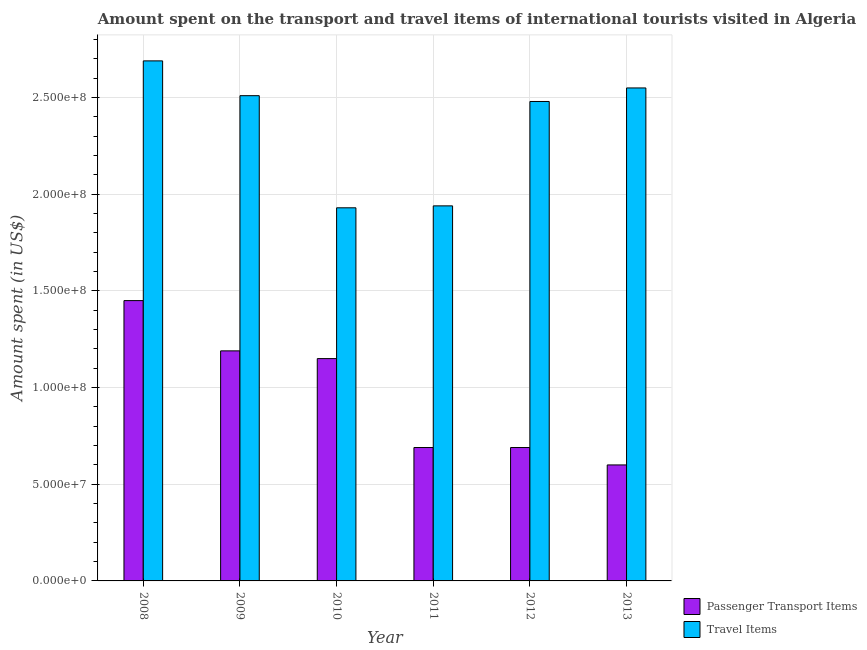Are the number of bars on each tick of the X-axis equal?
Offer a very short reply. Yes. How many bars are there on the 5th tick from the right?
Ensure brevity in your answer.  2. What is the label of the 2nd group of bars from the left?
Keep it short and to the point. 2009. What is the amount spent on passenger transport items in 2013?
Provide a short and direct response. 6.00e+07. Across all years, what is the maximum amount spent in travel items?
Offer a very short reply. 2.69e+08. Across all years, what is the minimum amount spent in travel items?
Provide a short and direct response. 1.93e+08. In which year was the amount spent on passenger transport items maximum?
Offer a terse response. 2008. In which year was the amount spent in travel items minimum?
Your response must be concise. 2010. What is the total amount spent on passenger transport items in the graph?
Offer a terse response. 5.77e+08. What is the difference between the amount spent in travel items in 2011 and that in 2013?
Make the answer very short. -6.10e+07. What is the difference between the amount spent in travel items in 2012 and the amount spent on passenger transport items in 2008?
Give a very brief answer. -2.10e+07. What is the average amount spent on passenger transport items per year?
Provide a short and direct response. 9.62e+07. What is the ratio of the amount spent in travel items in 2008 to that in 2011?
Give a very brief answer. 1.39. What is the difference between the highest and the second highest amount spent on passenger transport items?
Your answer should be compact. 2.60e+07. What is the difference between the highest and the lowest amount spent on passenger transport items?
Provide a short and direct response. 8.50e+07. Is the sum of the amount spent in travel items in 2010 and 2012 greater than the maximum amount spent on passenger transport items across all years?
Make the answer very short. Yes. What does the 2nd bar from the left in 2012 represents?
Provide a short and direct response. Travel Items. What does the 1st bar from the right in 2009 represents?
Your answer should be compact. Travel Items. How many bars are there?
Give a very brief answer. 12. Are all the bars in the graph horizontal?
Give a very brief answer. No. What is the difference between two consecutive major ticks on the Y-axis?
Your answer should be compact. 5.00e+07. Does the graph contain any zero values?
Make the answer very short. No. Does the graph contain grids?
Make the answer very short. Yes. Where does the legend appear in the graph?
Offer a terse response. Bottom right. How many legend labels are there?
Ensure brevity in your answer.  2. How are the legend labels stacked?
Ensure brevity in your answer.  Vertical. What is the title of the graph?
Your answer should be very brief. Amount spent on the transport and travel items of international tourists visited in Algeria. Does "Urban agglomerations" appear as one of the legend labels in the graph?
Your answer should be very brief. No. What is the label or title of the X-axis?
Offer a terse response. Year. What is the label or title of the Y-axis?
Your response must be concise. Amount spent (in US$). What is the Amount spent (in US$) of Passenger Transport Items in 2008?
Provide a succinct answer. 1.45e+08. What is the Amount spent (in US$) in Travel Items in 2008?
Your answer should be very brief. 2.69e+08. What is the Amount spent (in US$) in Passenger Transport Items in 2009?
Your answer should be compact. 1.19e+08. What is the Amount spent (in US$) of Travel Items in 2009?
Offer a very short reply. 2.51e+08. What is the Amount spent (in US$) in Passenger Transport Items in 2010?
Keep it short and to the point. 1.15e+08. What is the Amount spent (in US$) in Travel Items in 2010?
Your answer should be compact. 1.93e+08. What is the Amount spent (in US$) in Passenger Transport Items in 2011?
Your answer should be very brief. 6.90e+07. What is the Amount spent (in US$) of Travel Items in 2011?
Offer a very short reply. 1.94e+08. What is the Amount spent (in US$) of Passenger Transport Items in 2012?
Provide a succinct answer. 6.90e+07. What is the Amount spent (in US$) of Travel Items in 2012?
Provide a short and direct response. 2.48e+08. What is the Amount spent (in US$) in Passenger Transport Items in 2013?
Your response must be concise. 6.00e+07. What is the Amount spent (in US$) in Travel Items in 2013?
Offer a very short reply. 2.55e+08. Across all years, what is the maximum Amount spent (in US$) in Passenger Transport Items?
Keep it short and to the point. 1.45e+08. Across all years, what is the maximum Amount spent (in US$) of Travel Items?
Your answer should be very brief. 2.69e+08. Across all years, what is the minimum Amount spent (in US$) of Passenger Transport Items?
Make the answer very short. 6.00e+07. Across all years, what is the minimum Amount spent (in US$) in Travel Items?
Ensure brevity in your answer.  1.93e+08. What is the total Amount spent (in US$) in Passenger Transport Items in the graph?
Provide a short and direct response. 5.77e+08. What is the total Amount spent (in US$) of Travel Items in the graph?
Make the answer very short. 1.41e+09. What is the difference between the Amount spent (in US$) in Passenger Transport Items in 2008 and that in 2009?
Offer a terse response. 2.60e+07. What is the difference between the Amount spent (in US$) in Travel Items in 2008 and that in 2009?
Give a very brief answer. 1.80e+07. What is the difference between the Amount spent (in US$) in Passenger Transport Items in 2008 and that in 2010?
Your answer should be compact. 3.00e+07. What is the difference between the Amount spent (in US$) in Travel Items in 2008 and that in 2010?
Offer a terse response. 7.60e+07. What is the difference between the Amount spent (in US$) in Passenger Transport Items in 2008 and that in 2011?
Your answer should be very brief. 7.60e+07. What is the difference between the Amount spent (in US$) of Travel Items in 2008 and that in 2011?
Ensure brevity in your answer.  7.50e+07. What is the difference between the Amount spent (in US$) of Passenger Transport Items in 2008 and that in 2012?
Give a very brief answer. 7.60e+07. What is the difference between the Amount spent (in US$) in Travel Items in 2008 and that in 2012?
Ensure brevity in your answer.  2.10e+07. What is the difference between the Amount spent (in US$) in Passenger Transport Items in 2008 and that in 2013?
Offer a very short reply. 8.50e+07. What is the difference between the Amount spent (in US$) in Travel Items in 2008 and that in 2013?
Make the answer very short. 1.40e+07. What is the difference between the Amount spent (in US$) in Passenger Transport Items in 2009 and that in 2010?
Your answer should be very brief. 4.00e+06. What is the difference between the Amount spent (in US$) of Travel Items in 2009 and that in 2010?
Provide a short and direct response. 5.80e+07. What is the difference between the Amount spent (in US$) in Travel Items in 2009 and that in 2011?
Your response must be concise. 5.70e+07. What is the difference between the Amount spent (in US$) of Passenger Transport Items in 2009 and that in 2012?
Provide a succinct answer. 5.00e+07. What is the difference between the Amount spent (in US$) of Travel Items in 2009 and that in 2012?
Ensure brevity in your answer.  3.00e+06. What is the difference between the Amount spent (in US$) of Passenger Transport Items in 2009 and that in 2013?
Your answer should be compact. 5.90e+07. What is the difference between the Amount spent (in US$) in Travel Items in 2009 and that in 2013?
Provide a short and direct response. -4.00e+06. What is the difference between the Amount spent (in US$) in Passenger Transport Items in 2010 and that in 2011?
Offer a terse response. 4.60e+07. What is the difference between the Amount spent (in US$) in Travel Items in 2010 and that in 2011?
Provide a short and direct response. -1.00e+06. What is the difference between the Amount spent (in US$) in Passenger Transport Items in 2010 and that in 2012?
Ensure brevity in your answer.  4.60e+07. What is the difference between the Amount spent (in US$) in Travel Items in 2010 and that in 2012?
Your answer should be very brief. -5.50e+07. What is the difference between the Amount spent (in US$) of Passenger Transport Items in 2010 and that in 2013?
Your answer should be very brief. 5.50e+07. What is the difference between the Amount spent (in US$) of Travel Items in 2010 and that in 2013?
Provide a succinct answer. -6.20e+07. What is the difference between the Amount spent (in US$) of Passenger Transport Items in 2011 and that in 2012?
Make the answer very short. 0. What is the difference between the Amount spent (in US$) of Travel Items in 2011 and that in 2012?
Provide a short and direct response. -5.40e+07. What is the difference between the Amount spent (in US$) in Passenger Transport Items in 2011 and that in 2013?
Offer a very short reply. 9.00e+06. What is the difference between the Amount spent (in US$) of Travel Items in 2011 and that in 2013?
Offer a terse response. -6.10e+07. What is the difference between the Amount spent (in US$) of Passenger Transport Items in 2012 and that in 2013?
Ensure brevity in your answer.  9.00e+06. What is the difference between the Amount spent (in US$) in Travel Items in 2012 and that in 2013?
Make the answer very short. -7.00e+06. What is the difference between the Amount spent (in US$) in Passenger Transport Items in 2008 and the Amount spent (in US$) in Travel Items in 2009?
Keep it short and to the point. -1.06e+08. What is the difference between the Amount spent (in US$) of Passenger Transport Items in 2008 and the Amount spent (in US$) of Travel Items in 2010?
Your response must be concise. -4.80e+07. What is the difference between the Amount spent (in US$) of Passenger Transport Items in 2008 and the Amount spent (in US$) of Travel Items in 2011?
Provide a succinct answer. -4.90e+07. What is the difference between the Amount spent (in US$) in Passenger Transport Items in 2008 and the Amount spent (in US$) in Travel Items in 2012?
Keep it short and to the point. -1.03e+08. What is the difference between the Amount spent (in US$) of Passenger Transport Items in 2008 and the Amount spent (in US$) of Travel Items in 2013?
Offer a terse response. -1.10e+08. What is the difference between the Amount spent (in US$) in Passenger Transport Items in 2009 and the Amount spent (in US$) in Travel Items in 2010?
Offer a very short reply. -7.40e+07. What is the difference between the Amount spent (in US$) of Passenger Transport Items in 2009 and the Amount spent (in US$) of Travel Items in 2011?
Your answer should be compact. -7.50e+07. What is the difference between the Amount spent (in US$) in Passenger Transport Items in 2009 and the Amount spent (in US$) in Travel Items in 2012?
Your answer should be compact. -1.29e+08. What is the difference between the Amount spent (in US$) of Passenger Transport Items in 2009 and the Amount spent (in US$) of Travel Items in 2013?
Your answer should be compact. -1.36e+08. What is the difference between the Amount spent (in US$) of Passenger Transport Items in 2010 and the Amount spent (in US$) of Travel Items in 2011?
Ensure brevity in your answer.  -7.90e+07. What is the difference between the Amount spent (in US$) of Passenger Transport Items in 2010 and the Amount spent (in US$) of Travel Items in 2012?
Keep it short and to the point. -1.33e+08. What is the difference between the Amount spent (in US$) in Passenger Transport Items in 2010 and the Amount spent (in US$) in Travel Items in 2013?
Ensure brevity in your answer.  -1.40e+08. What is the difference between the Amount spent (in US$) of Passenger Transport Items in 2011 and the Amount spent (in US$) of Travel Items in 2012?
Your answer should be very brief. -1.79e+08. What is the difference between the Amount spent (in US$) in Passenger Transport Items in 2011 and the Amount spent (in US$) in Travel Items in 2013?
Keep it short and to the point. -1.86e+08. What is the difference between the Amount spent (in US$) of Passenger Transport Items in 2012 and the Amount spent (in US$) of Travel Items in 2013?
Provide a succinct answer. -1.86e+08. What is the average Amount spent (in US$) in Passenger Transport Items per year?
Offer a terse response. 9.62e+07. What is the average Amount spent (in US$) in Travel Items per year?
Provide a short and direct response. 2.35e+08. In the year 2008, what is the difference between the Amount spent (in US$) in Passenger Transport Items and Amount spent (in US$) in Travel Items?
Your answer should be very brief. -1.24e+08. In the year 2009, what is the difference between the Amount spent (in US$) of Passenger Transport Items and Amount spent (in US$) of Travel Items?
Your response must be concise. -1.32e+08. In the year 2010, what is the difference between the Amount spent (in US$) of Passenger Transport Items and Amount spent (in US$) of Travel Items?
Give a very brief answer. -7.80e+07. In the year 2011, what is the difference between the Amount spent (in US$) of Passenger Transport Items and Amount spent (in US$) of Travel Items?
Provide a succinct answer. -1.25e+08. In the year 2012, what is the difference between the Amount spent (in US$) of Passenger Transport Items and Amount spent (in US$) of Travel Items?
Provide a short and direct response. -1.79e+08. In the year 2013, what is the difference between the Amount spent (in US$) in Passenger Transport Items and Amount spent (in US$) in Travel Items?
Your response must be concise. -1.95e+08. What is the ratio of the Amount spent (in US$) in Passenger Transport Items in 2008 to that in 2009?
Provide a succinct answer. 1.22. What is the ratio of the Amount spent (in US$) in Travel Items in 2008 to that in 2009?
Your answer should be very brief. 1.07. What is the ratio of the Amount spent (in US$) in Passenger Transport Items in 2008 to that in 2010?
Offer a very short reply. 1.26. What is the ratio of the Amount spent (in US$) of Travel Items in 2008 to that in 2010?
Your answer should be very brief. 1.39. What is the ratio of the Amount spent (in US$) of Passenger Transport Items in 2008 to that in 2011?
Ensure brevity in your answer.  2.1. What is the ratio of the Amount spent (in US$) in Travel Items in 2008 to that in 2011?
Your answer should be compact. 1.39. What is the ratio of the Amount spent (in US$) of Passenger Transport Items in 2008 to that in 2012?
Your answer should be very brief. 2.1. What is the ratio of the Amount spent (in US$) of Travel Items in 2008 to that in 2012?
Give a very brief answer. 1.08. What is the ratio of the Amount spent (in US$) of Passenger Transport Items in 2008 to that in 2013?
Keep it short and to the point. 2.42. What is the ratio of the Amount spent (in US$) of Travel Items in 2008 to that in 2013?
Keep it short and to the point. 1.05. What is the ratio of the Amount spent (in US$) in Passenger Transport Items in 2009 to that in 2010?
Provide a short and direct response. 1.03. What is the ratio of the Amount spent (in US$) of Travel Items in 2009 to that in 2010?
Your response must be concise. 1.3. What is the ratio of the Amount spent (in US$) in Passenger Transport Items in 2009 to that in 2011?
Provide a succinct answer. 1.72. What is the ratio of the Amount spent (in US$) of Travel Items in 2009 to that in 2011?
Ensure brevity in your answer.  1.29. What is the ratio of the Amount spent (in US$) of Passenger Transport Items in 2009 to that in 2012?
Your response must be concise. 1.72. What is the ratio of the Amount spent (in US$) in Travel Items in 2009 to that in 2012?
Keep it short and to the point. 1.01. What is the ratio of the Amount spent (in US$) in Passenger Transport Items in 2009 to that in 2013?
Make the answer very short. 1.98. What is the ratio of the Amount spent (in US$) of Travel Items in 2009 to that in 2013?
Make the answer very short. 0.98. What is the ratio of the Amount spent (in US$) of Passenger Transport Items in 2010 to that in 2011?
Provide a succinct answer. 1.67. What is the ratio of the Amount spent (in US$) of Travel Items in 2010 to that in 2011?
Provide a short and direct response. 0.99. What is the ratio of the Amount spent (in US$) of Travel Items in 2010 to that in 2012?
Give a very brief answer. 0.78. What is the ratio of the Amount spent (in US$) of Passenger Transport Items in 2010 to that in 2013?
Keep it short and to the point. 1.92. What is the ratio of the Amount spent (in US$) of Travel Items in 2010 to that in 2013?
Offer a very short reply. 0.76. What is the ratio of the Amount spent (in US$) of Passenger Transport Items in 2011 to that in 2012?
Provide a short and direct response. 1. What is the ratio of the Amount spent (in US$) in Travel Items in 2011 to that in 2012?
Keep it short and to the point. 0.78. What is the ratio of the Amount spent (in US$) of Passenger Transport Items in 2011 to that in 2013?
Ensure brevity in your answer.  1.15. What is the ratio of the Amount spent (in US$) in Travel Items in 2011 to that in 2013?
Offer a very short reply. 0.76. What is the ratio of the Amount spent (in US$) in Passenger Transport Items in 2012 to that in 2013?
Your answer should be compact. 1.15. What is the ratio of the Amount spent (in US$) in Travel Items in 2012 to that in 2013?
Your response must be concise. 0.97. What is the difference between the highest and the second highest Amount spent (in US$) of Passenger Transport Items?
Your answer should be very brief. 2.60e+07. What is the difference between the highest and the second highest Amount spent (in US$) of Travel Items?
Your response must be concise. 1.40e+07. What is the difference between the highest and the lowest Amount spent (in US$) in Passenger Transport Items?
Provide a succinct answer. 8.50e+07. What is the difference between the highest and the lowest Amount spent (in US$) of Travel Items?
Your answer should be very brief. 7.60e+07. 